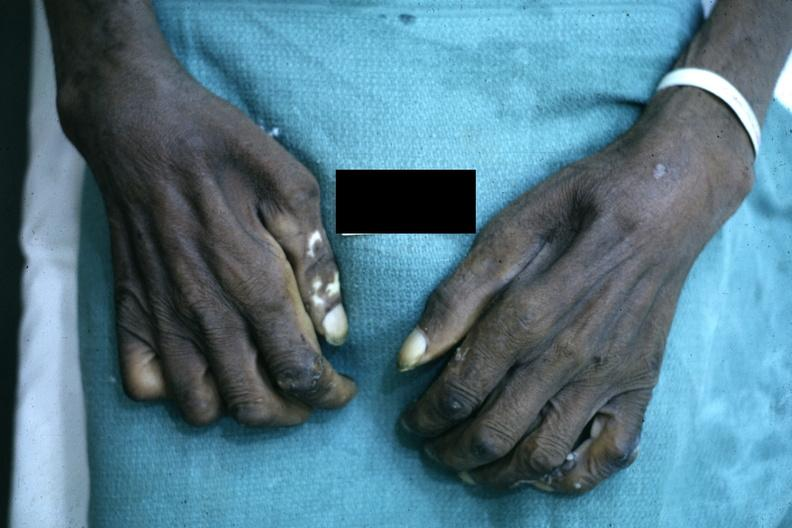does this image show close-up excellent example of interosseous muscle atrophy said to be due to syringomyelus?
Answer the question using a single word or phrase. Yes 